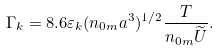<formula> <loc_0><loc_0><loc_500><loc_500>\Gamma _ { k } = 8 . 6 \varepsilon _ { k } ( n _ { 0 m } a ^ { 3 } ) ^ { 1 / 2 } \frac { T } { n _ { 0 m } \widetilde { U } } .</formula> 